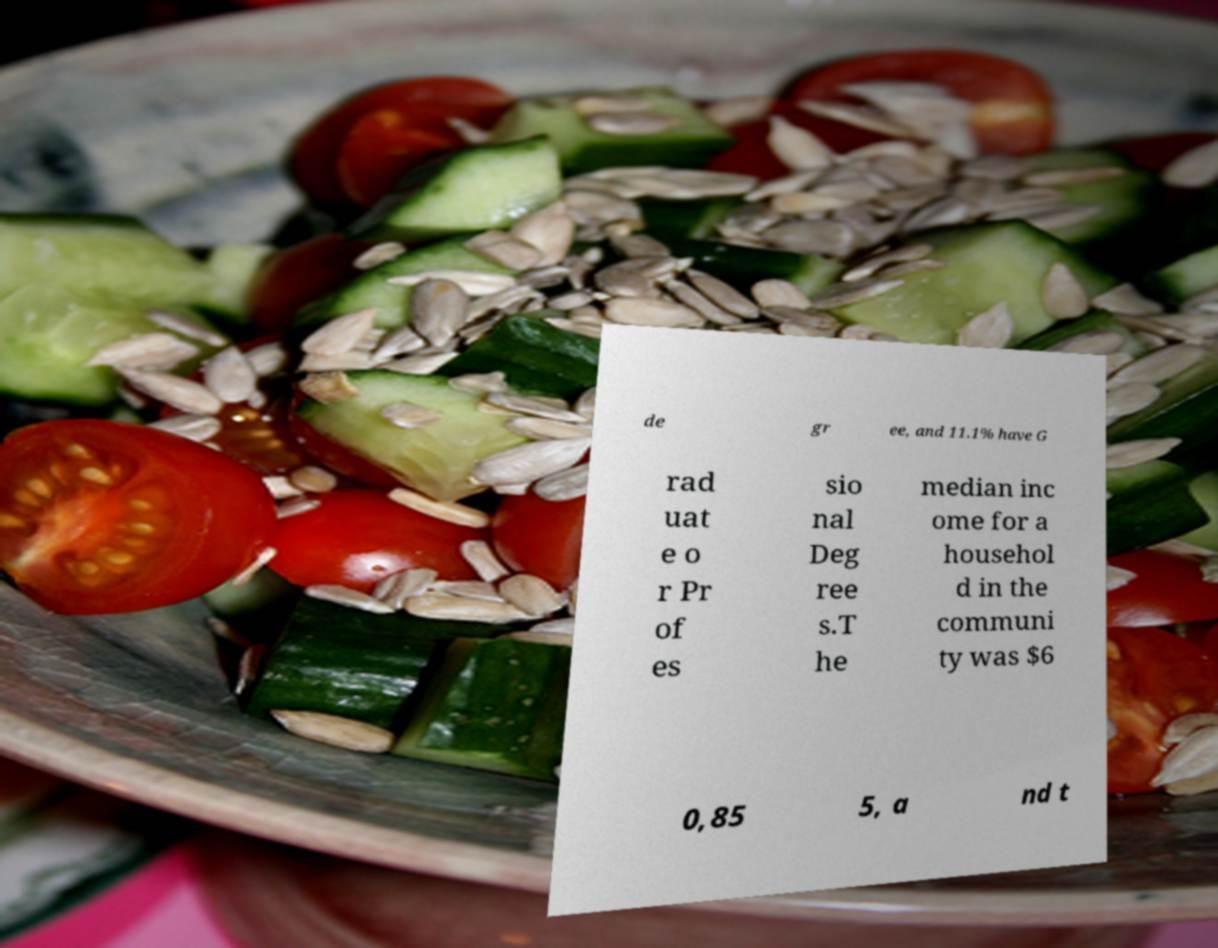There's text embedded in this image that I need extracted. Can you transcribe it verbatim? de gr ee, and 11.1% have G rad uat e o r Pr of es sio nal Deg ree s.T he median inc ome for a househol d in the communi ty was $6 0,85 5, a nd t 